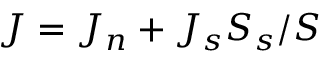<formula> <loc_0><loc_0><loc_500><loc_500>J = J _ { n } + J _ { s } S _ { s } / S</formula> 